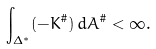<formula> <loc_0><loc_0><loc_500><loc_500>\int _ { \Delta ^ { * } } ( - K ^ { \# } ) \, d A ^ { \# } < \infty .</formula> 